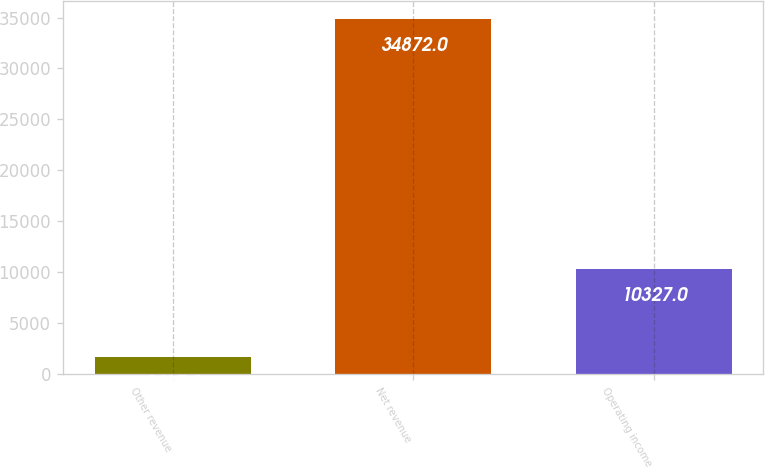Convert chart to OTSL. <chart><loc_0><loc_0><loc_500><loc_500><bar_chart><fcel>Other revenue<fcel>Net revenue<fcel>Operating income<nl><fcel>1637<fcel>34872<fcel>10327<nl></chart> 